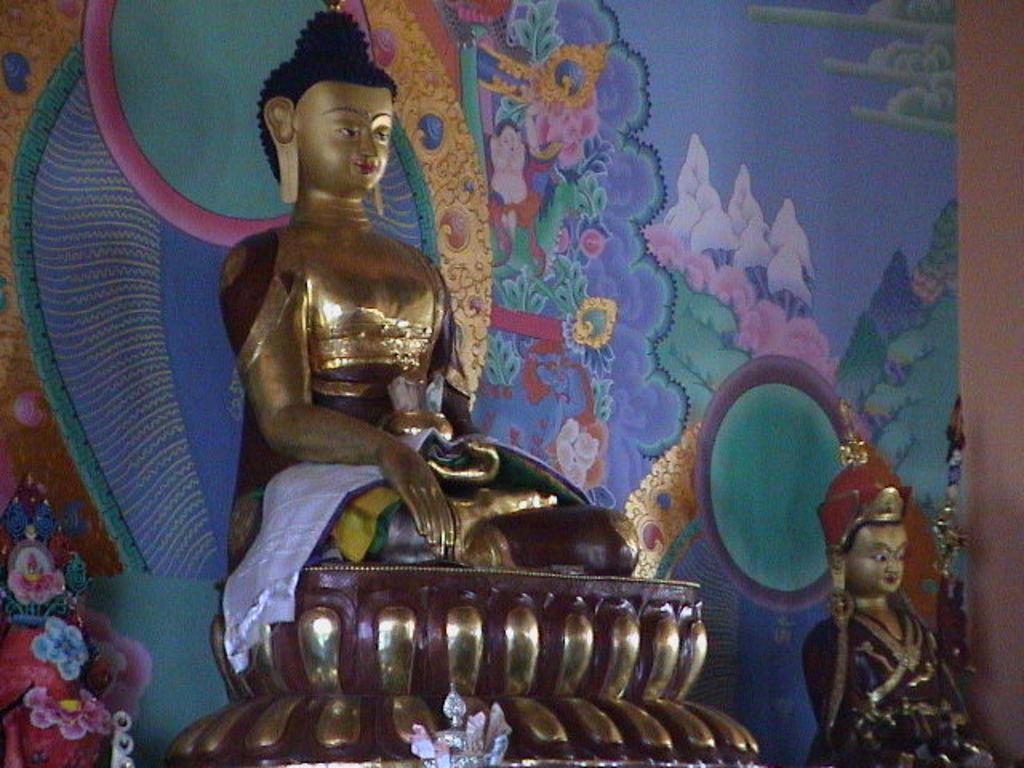Please provide a concise description of this image. Here there are sculptures. 